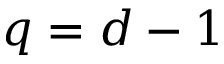Convert formula to latex. <formula><loc_0><loc_0><loc_500><loc_500>q = d - 1</formula> 